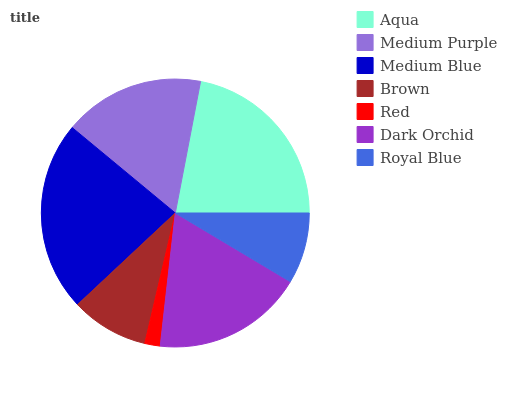Is Red the minimum?
Answer yes or no. Yes. Is Medium Blue the maximum?
Answer yes or no. Yes. Is Medium Purple the minimum?
Answer yes or no. No. Is Medium Purple the maximum?
Answer yes or no. No. Is Aqua greater than Medium Purple?
Answer yes or no. Yes. Is Medium Purple less than Aqua?
Answer yes or no. Yes. Is Medium Purple greater than Aqua?
Answer yes or no. No. Is Aqua less than Medium Purple?
Answer yes or no. No. Is Medium Purple the high median?
Answer yes or no. Yes. Is Medium Purple the low median?
Answer yes or no. Yes. Is Red the high median?
Answer yes or no. No. Is Brown the low median?
Answer yes or no. No. 